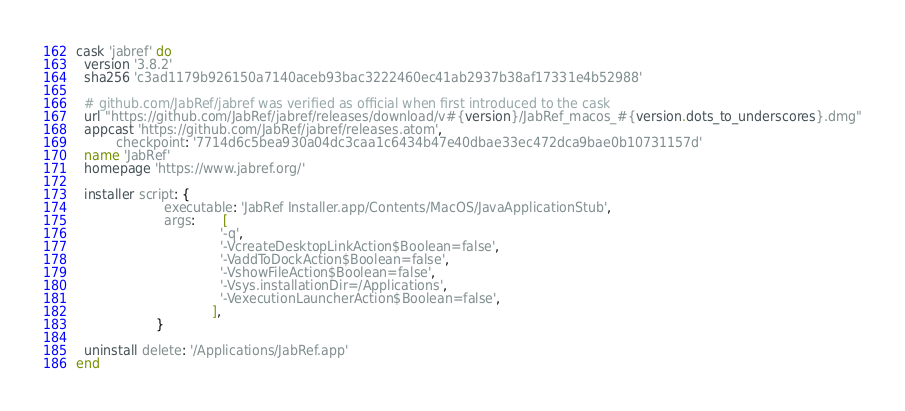Convert code to text. <code><loc_0><loc_0><loc_500><loc_500><_Ruby_>cask 'jabref' do
  version '3.8.2'
  sha256 'c3ad1179b926150a7140aceb93bac3222460ec41ab2937b38af17331e4b52988'

  # github.com/JabRef/jabref was verified as official when first introduced to the cask
  url "https://github.com/JabRef/jabref/releases/download/v#{version}/JabRef_macos_#{version.dots_to_underscores}.dmg"
  appcast 'https://github.com/JabRef/jabref/releases.atom',
          checkpoint: '7714d6c5bea930a04dc3caa1c6434b47e40dbae33ec472dca9bae0b10731157d'
  name 'JabRef'
  homepage 'https://www.jabref.org/'

  installer script: {
                      executable: 'JabRef Installer.app/Contents/MacOS/JavaApplicationStub',
                      args:       [
                                    '-q',
                                    '-VcreateDesktopLinkAction$Boolean=false',
                                    '-VaddToDockAction$Boolean=false',
                                    '-VshowFileAction$Boolean=false',
                                    '-Vsys.installationDir=/Applications',
                                    '-VexecutionLauncherAction$Boolean=false',
                                  ],
                    }

  uninstall delete: '/Applications/JabRef.app'
end
</code> 